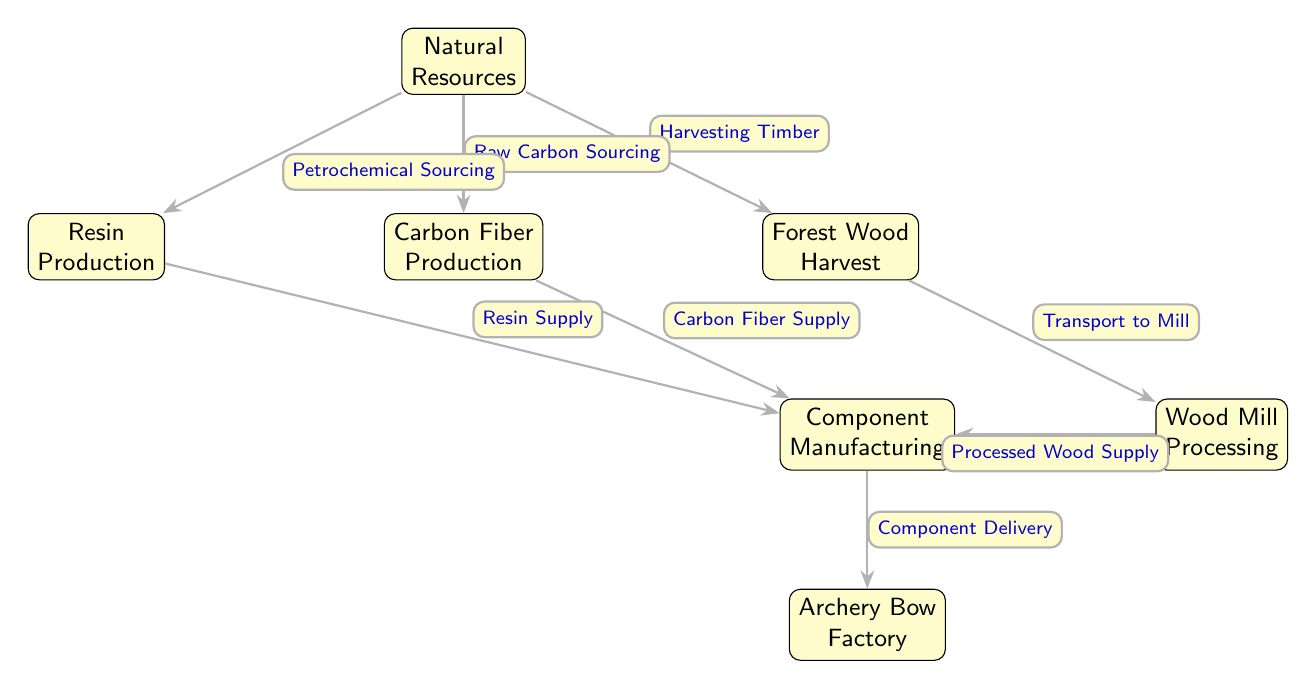What is the first node in the food chain? The diagram starts with "Natural Resources" at the top, which represents the initial source of materials for the bow manufacturing process.
Answer: Natural Resources How many edges are there in the diagram? Each edge represents a connection or flow from one node to another. Counting all the arrows in the diagram, there are a total of 7 edges.
Answer: 7 What is the last step before the archery bow factory? The last step before reaching the "Archery Bow Factory" is "Component Delivery", which signifies the final process of delivering components manufactured earlier.
Answer: Component Delivery From which node does the wood mill processing receive input? The "Wood Mill Processing" receives input from the "Forest Wood Harvest" node, indicating that processed wood comes from the harvested timber.
Answer: Forest Wood Harvest What two types of resources are sourced from natural resources for component manufacturing? The diagram shows that both "Carbon Fiber Supply" and "Resin Supply" are sourced from "Natural Resources" to be used in component manufacturing.
Answer: Carbon Fiber Supply and Resin Supply Which processing step involves petrochemical sourcing? The step that involves petrochemical sourcing is "Resin Production," which indicates that resin is created using petrochemical resources.
Answer: Resin Production How does the carbon fiber production contribute to the component manufacturing? "Carbon Fiber Production" contributes by supplying carbon fiber directly to the "Component Manufacturing" node, indicating a flow of this specific material.
Answer: Carbon Fiber Supply What step comes after processing wood supply? After "Processed Wood Supply," the next step in the chain is "Component Manufacturing," where the processed wood is utilized to create archery components.
Answer: Component Manufacturing 